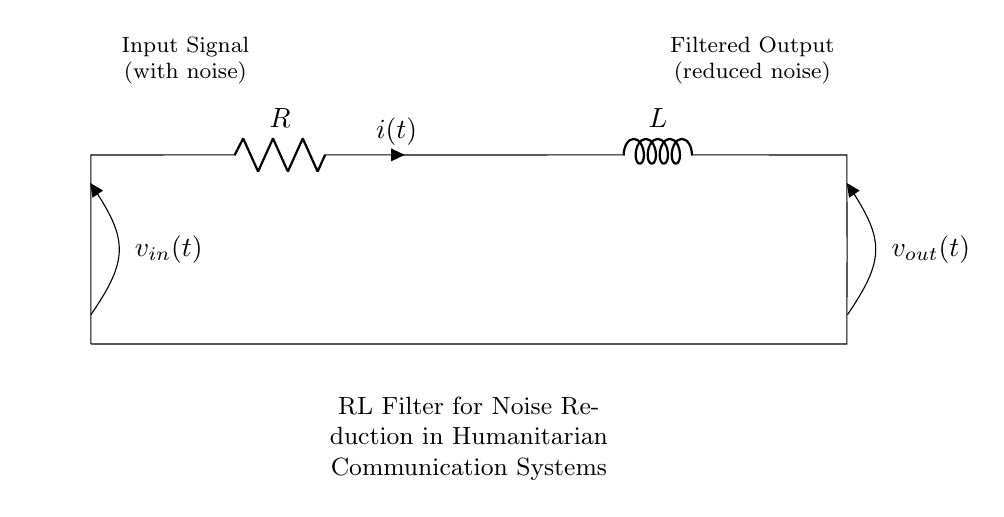What components are present in this circuit? The circuit contains a resistor and an inductor which are connected in series. These are the only two components visible in the diagram.
Answer: Resistor and Inductor What is the purpose of this circuit? The stated purpose of the circuit, as indicated in the label, is to filter noise from communication systems during humanitarian missions. This involves reducing unwanted disturbances in the input signal.
Answer: Noise reduction What does the input signal represent? The input signal, as shown in the circuit, is described as a signal that contains noise. This highlights that the circuit is designed to improve signal quality by filtering out this noise.
Answer: Input signal with noise What is the output of the circuit? The output of the circuit is labeled as the filtered output, which has reduced noise compared to the input. Thus, it indicates the effectiveness of the filtering process.
Answer: Filtered output How are the resistor and inductor connected? The resistor and inductor are connected in series according to the diagram, meaning the current passing through the resistor also flows through the inductor. This arrangement is typical for creating an RL filter configuration.
Answer: In series What is the relationship between voltage and current in this circuit? In an RL circuit such as this, the voltage across the components will relate to both the resistance and the inductance as per Ohm's law and inductive reactance. Understanding this relationship is key to analyzing how effectively the circuit can filter signals.
Answer: Ohm's law and inductive reactance What does the label "v_out" signify in the circuit? The label "v_out" signifies the output voltage of the circuit, which is the voltage available at the point after the inductor, reflecting the filtered signal's quality after noise reduction.
Answer: Output voltage 